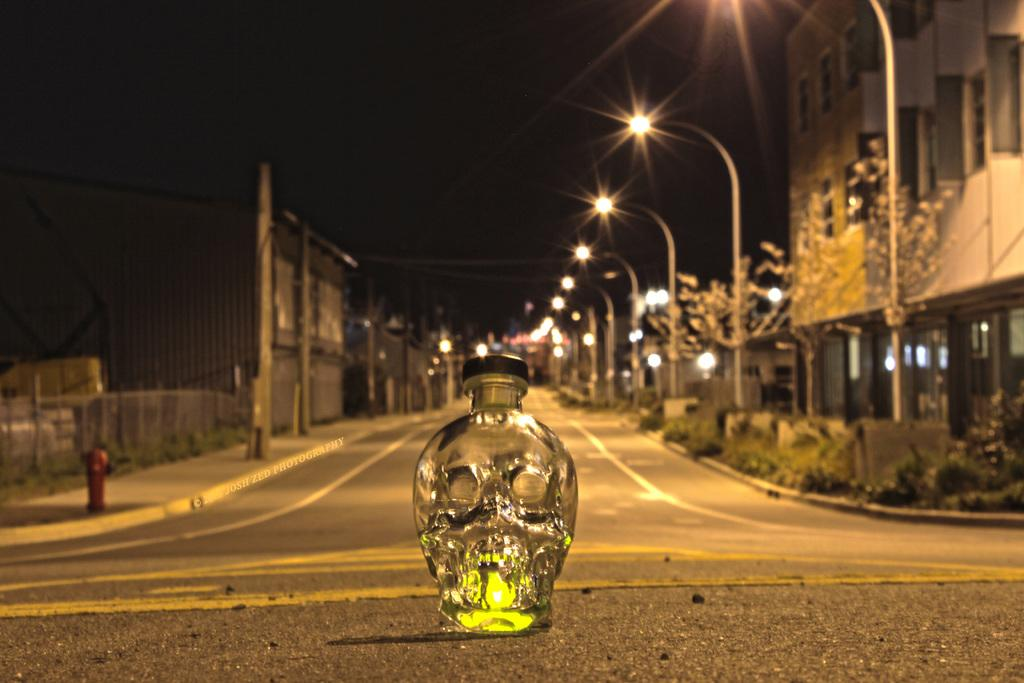What type of location is depicted in the image? The image is of a street. What structures can be seen along the street? There are buildings and poles along the street. What additional features are present along the street? There are lights along the street. Can you describe an object on the road in the image? There is a glass bottle on the road, and it has a black color lid. What theory is being proposed in the image? There is no theory being proposed in the image; it is a depiction of a street with various structures and objects. What type of voyage is taking place in the image? There is no voyage depicted in the image; it is a static scene of a street. 